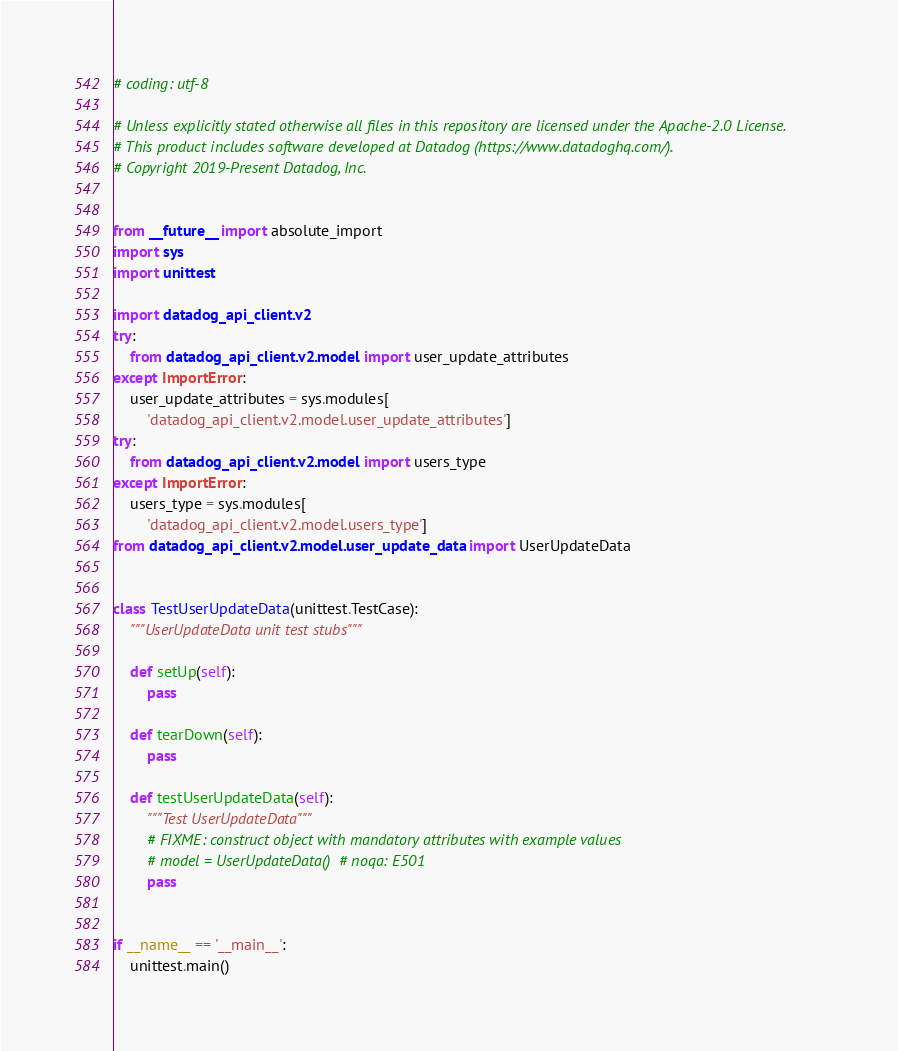<code> <loc_0><loc_0><loc_500><loc_500><_Python_># coding: utf-8

# Unless explicitly stated otherwise all files in this repository are licensed under the Apache-2.0 License.
# This product includes software developed at Datadog (https://www.datadoghq.com/).
# Copyright 2019-Present Datadog, Inc.


from __future__ import absolute_import
import sys
import unittest

import datadog_api_client.v2
try:
    from datadog_api_client.v2.model import user_update_attributes
except ImportError:
    user_update_attributes = sys.modules[
        'datadog_api_client.v2.model.user_update_attributes']
try:
    from datadog_api_client.v2.model import users_type
except ImportError:
    users_type = sys.modules[
        'datadog_api_client.v2.model.users_type']
from datadog_api_client.v2.model.user_update_data import UserUpdateData


class TestUserUpdateData(unittest.TestCase):
    """UserUpdateData unit test stubs"""

    def setUp(self):
        pass

    def tearDown(self):
        pass

    def testUserUpdateData(self):
        """Test UserUpdateData"""
        # FIXME: construct object with mandatory attributes with example values
        # model = UserUpdateData()  # noqa: E501
        pass


if __name__ == '__main__':
    unittest.main()
</code> 